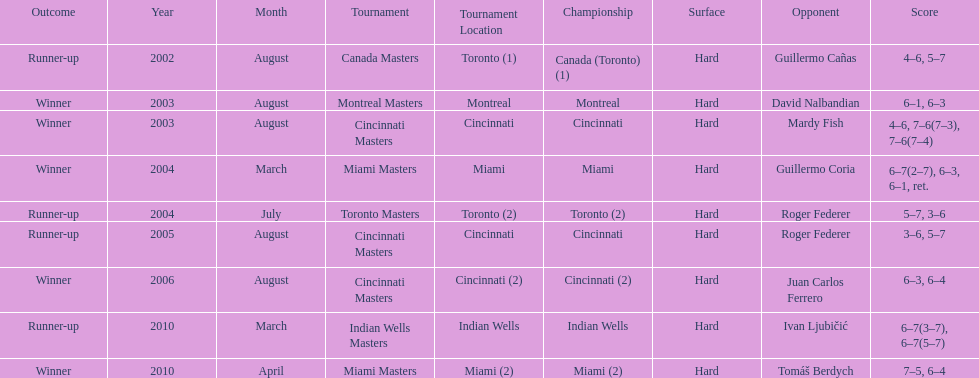How many total wins has he had? 5. 